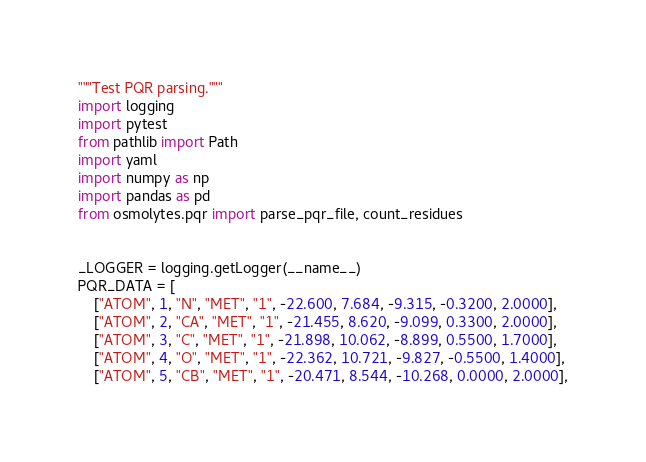<code> <loc_0><loc_0><loc_500><loc_500><_Python_>"""Test PQR parsing."""
import logging
import pytest
from pathlib import Path
import yaml
import numpy as np
import pandas as pd
from osmolytes.pqr import parse_pqr_file, count_residues


_LOGGER = logging.getLogger(__name__)
PQR_DATA = [
    ["ATOM", 1, "N", "MET", "1", -22.600, 7.684, -9.315, -0.3200, 2.0000],
    ["ATOM", 2, "CA", "MET", "1", -21.455, 8.620, -9.099, 0.3300, 2.0000],
    ["ATOM", 3, "C", "MET", "1", -21.898, 10.062, -8.899, 0.5500, 1.7000],
    ["ATOM", 4, "O", "MET", "1", -22.362, 10.721, -9.827, -0.5500, 1.4000],
    ["ATOM", 5, "CB", "MET", "1", -20.471, 8.544, -10.268, 0.0000, 2.0000],</code> 